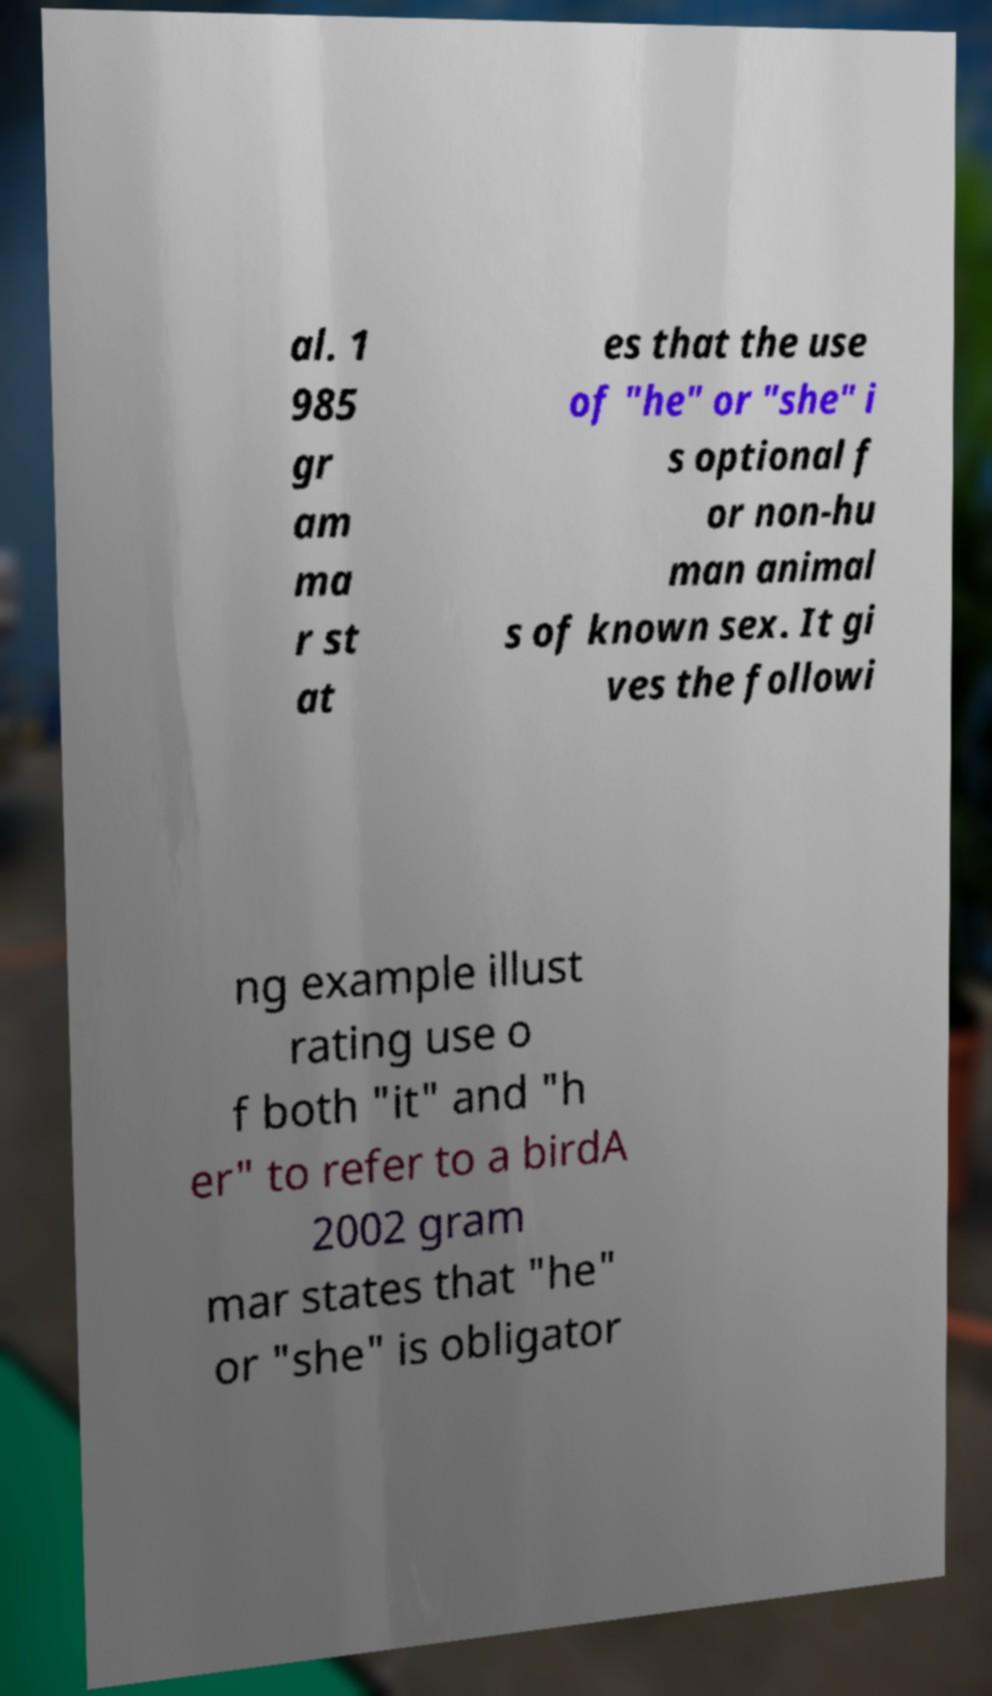What messages or text are displayed in this image? I need them in a readable, typed format. al. 1 985 gr am ma r st at es that the use of "he" or "she" i s optional f or non-hu man animal s of known sex. It gi ves the followi ng example illust rating use o f both "it" and "h er" to refer to a birdA 2002 gram mar states that "he" or "she" is obligator 